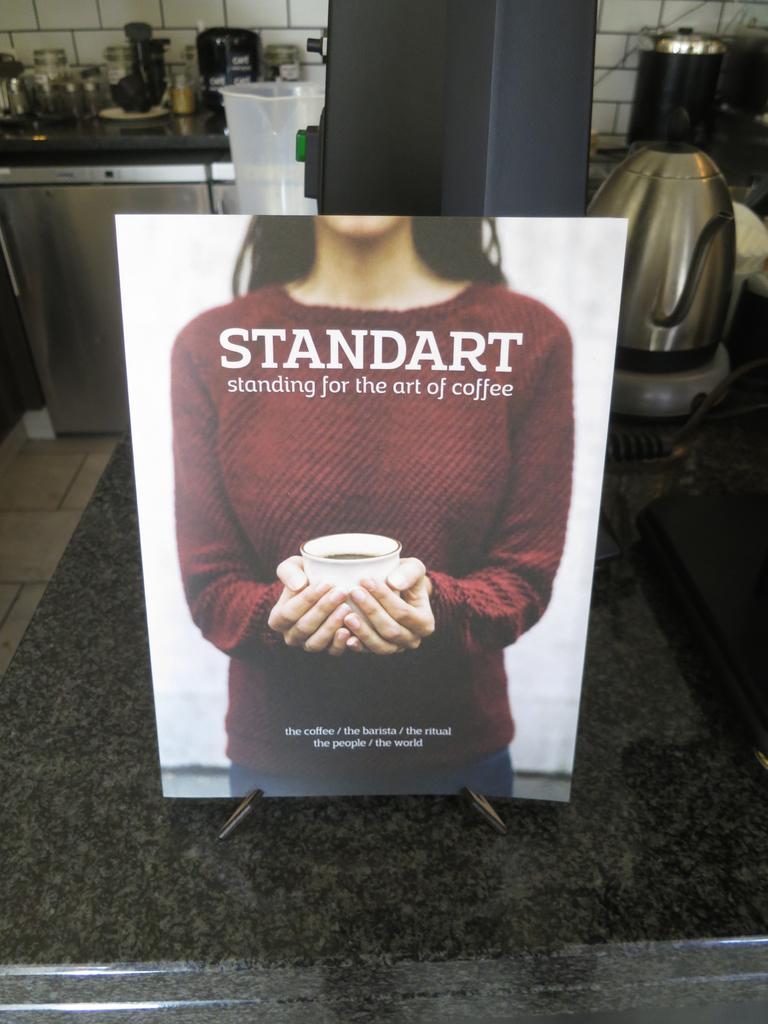How would you summarize this image in a sentence or two? In this image we can see a poster with pictures and some text is placed on the countertop. In the background, we can see, a kettle, jar, group of bowls, container, group of glasses placed on the table. 